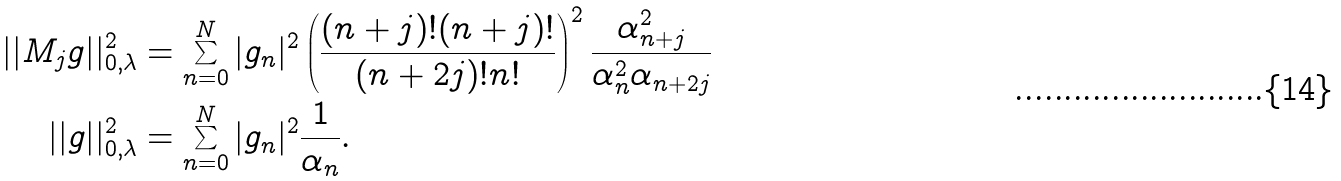<formula> <loc_0><loc_0><loc_500><loc_500>| | M _ { j } g | | _ { 0 , \lambda } ^ { 2 } & = \sum _ { n = 0 } ^ { N } | g _ { n } | ^ { 2 } \left ( \frac { ( n + j ) ! ( n + j ) ! } { ( n + 2 j ) ! n ! } \right ) ^ { 2 } \frac { \alpha _ { n + j } ^ { 2 } } { \alpha _ { n } ^ { 2 } \alpha _ { n + 2 j } } \\ | | g | | _ { 0 , \lambda } ^ { 2 } & = \sum _ { n = 0 } ^ { N } | g _ { n } | ^ { 2 } \frac { 1 } { \alpha _ { n } } .</formula> 